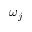Convert formula to latex. <formula><loc_0><loc_0><loc_500><loc_500>\omega _ { j }</formula> 